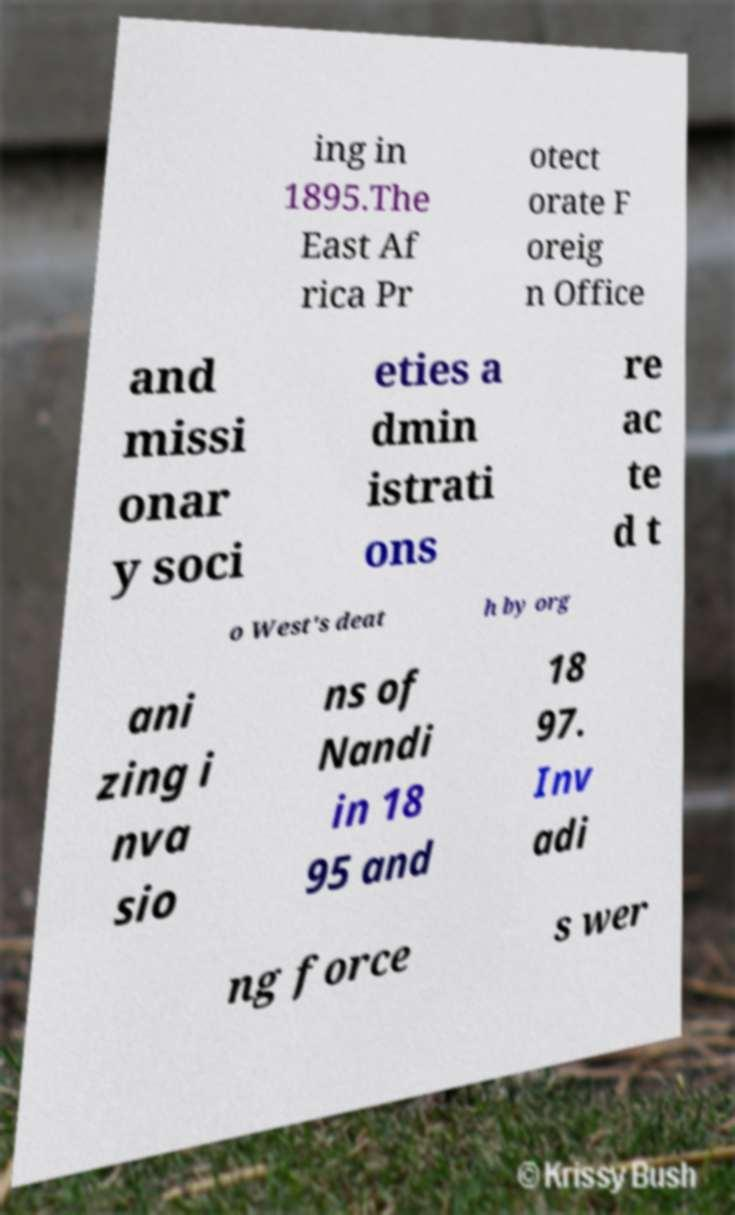For documentation purposes, I need the text within this image transcribed. Could you provide that? ing in 1895.The East Af rica Pr otect orate F oreig n Office and missi onar y soci eties a dmin istrati ons re ac te d t o West's deat h by org ani zing i nva sio ns of Nandi in 18 95 and 18 97. Inv adi ng force s wer 